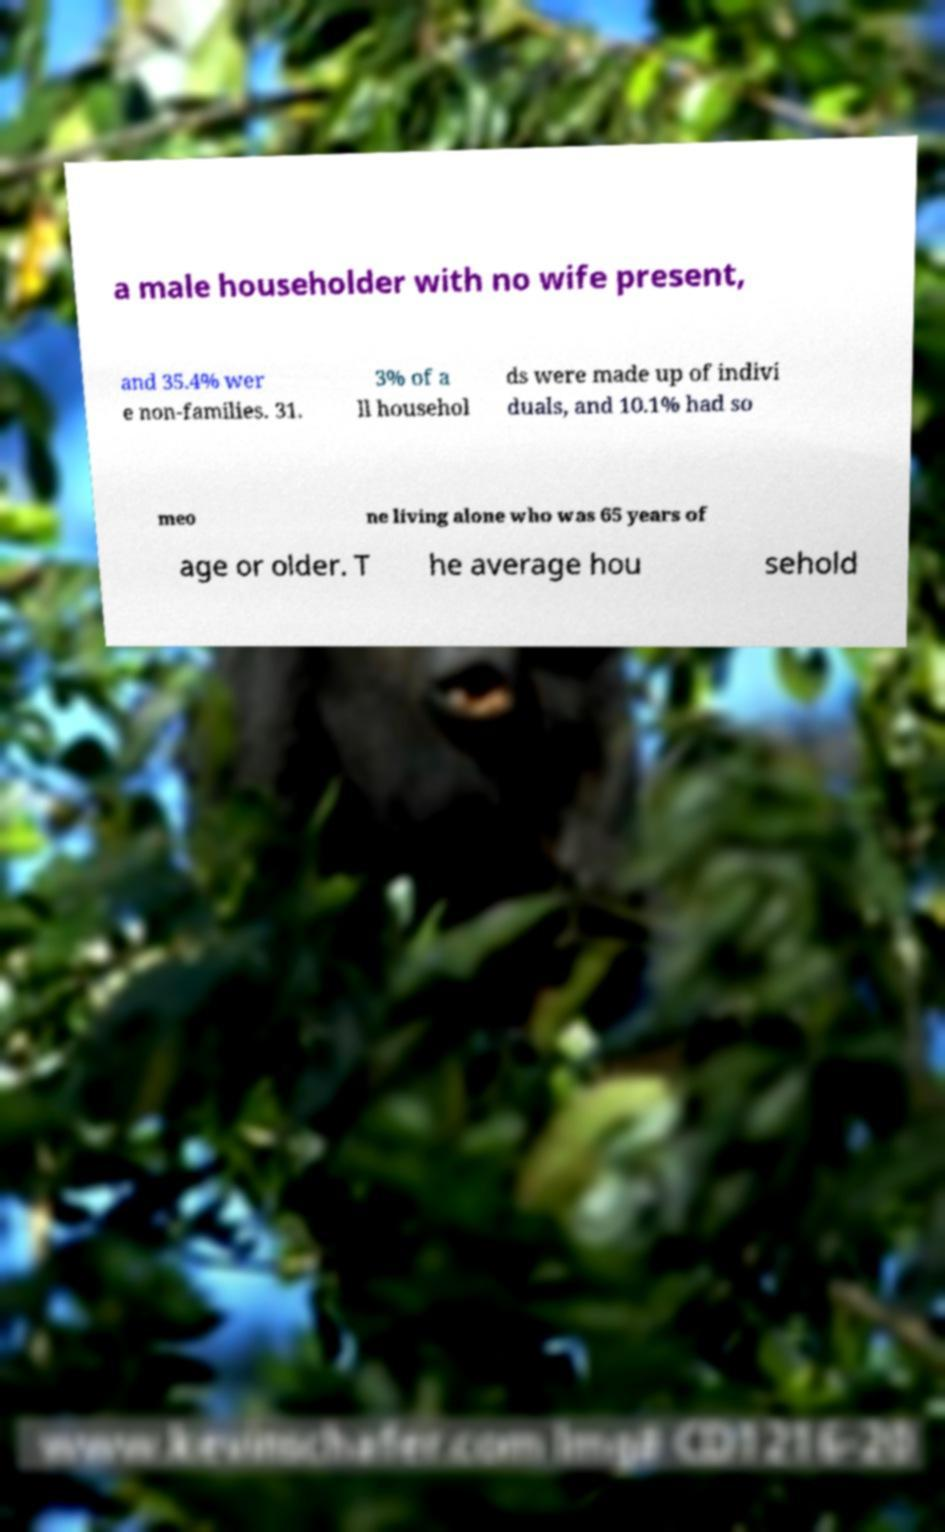I need the written content from this picture converted into text. Can you do that? a male householder with no wife present, and 35.4% wer e non-families. 31. 3% of a ll househol ds were made up of indivi duals, and 10.1% had so meo ne living alone who was 65 years of age or older. T he average hou sehold 